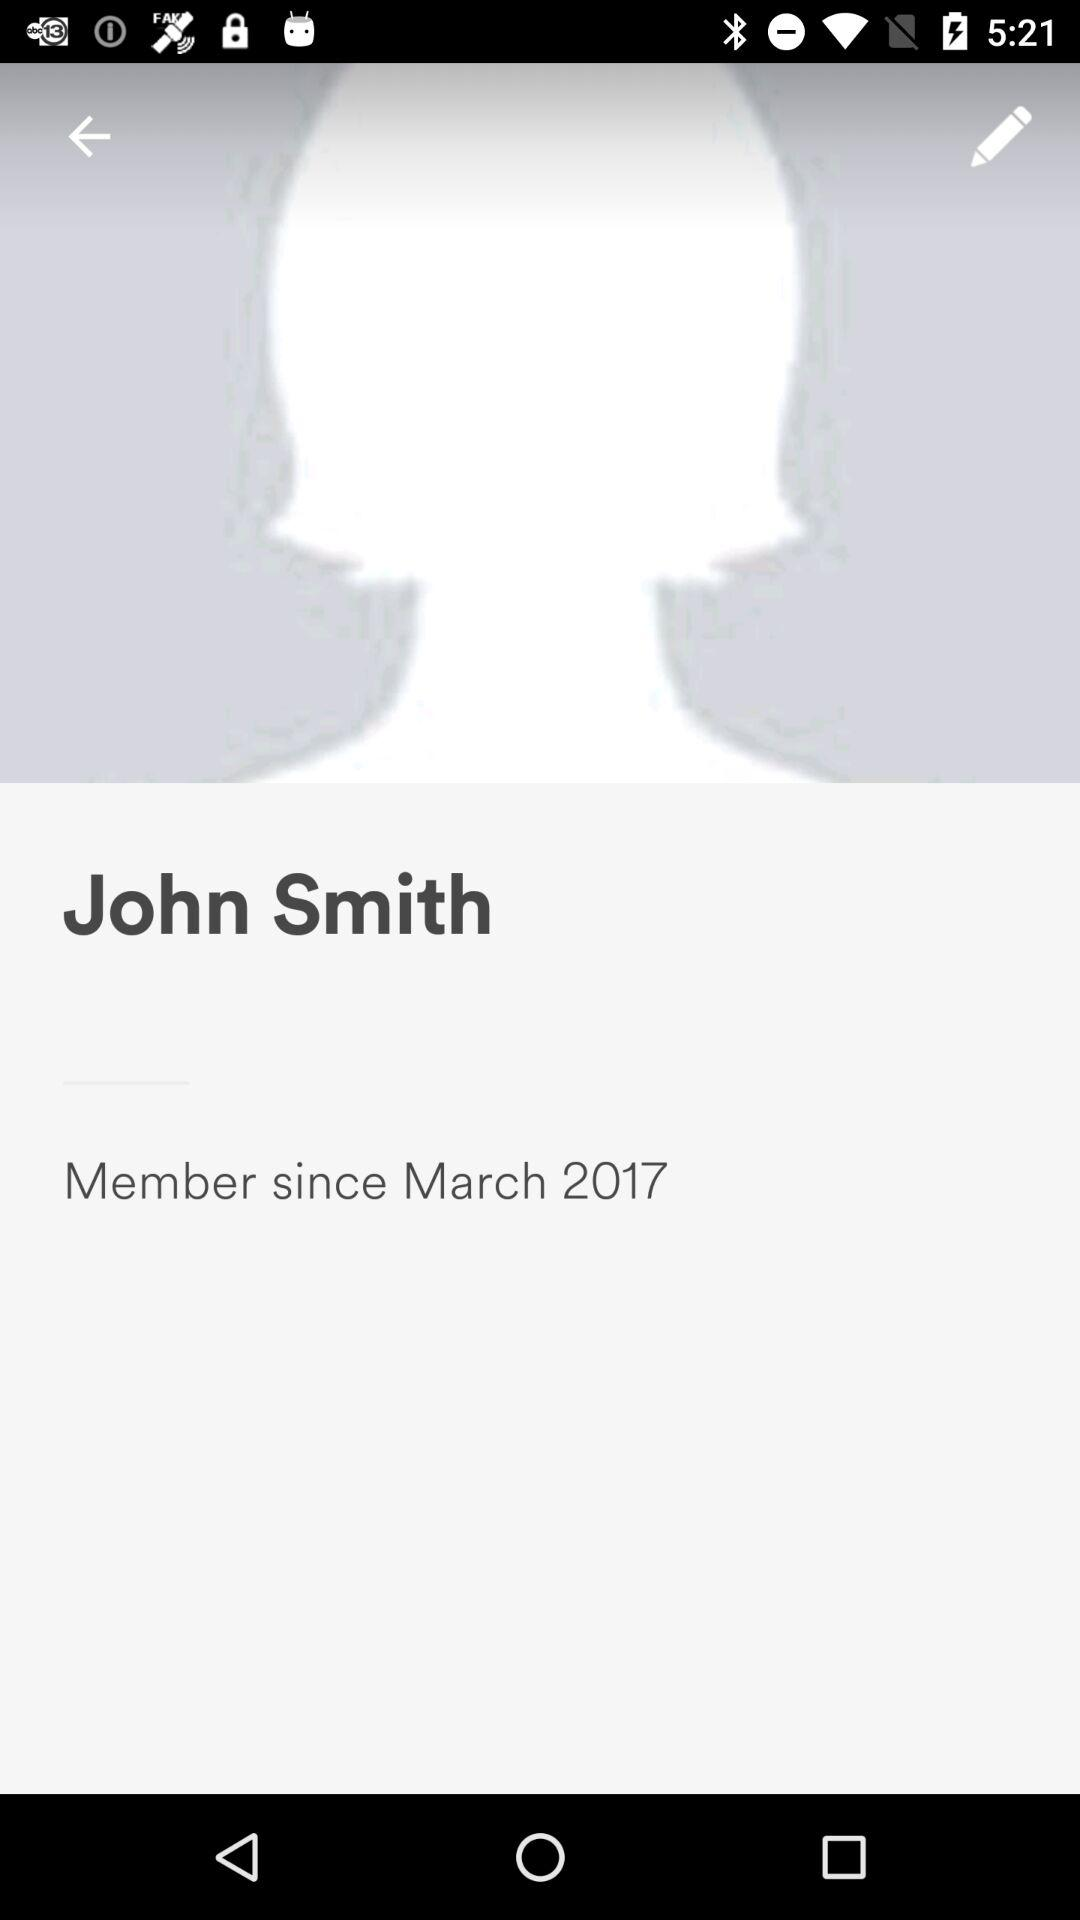Since when has John Smith been a member? John Smith has been a member since March 2017. 